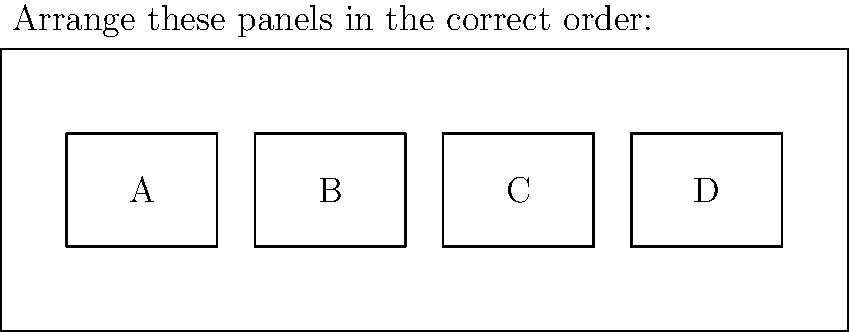As an artist creating custom 'The Tick' artwork, arrange the following comic panels in the correct sequential order to depict a typical scene from 'The Tick' series:

A: The Tick stands triumphantly on a rooftop
B: The Tick spots a crime in progress
C: The Tick leaps into action
D: The Tick defeats the villain

What is the correct order of these panels? To determine the correct order of the panels, we need to consider the typical structure of a superhero comic scene, especially one featuring The Tick:

1. The scene usually begins with the hero in a neutral position, often observing the city. This corresponds to panel A: "The Tick stands triumphantly on a rooftop".

2. The next logical step is for the hero to become aware of a situation that requires their intervention. This matches panel B: "The Tick spots a crime in progress".

3. Once the hero is aware of the crime, they would naturally spring into action. This is represented by panel C: "The Tick leaps into action".

4. The final step in a typical superhero scene is the resolution of the conflict, which in this case is panel D: "The Tick defeats the villain".

Therefore, the correct sequential order that best represents a typical scene from 'The Tick' series is A, B, C, D.
Answer: A, B, C, D 